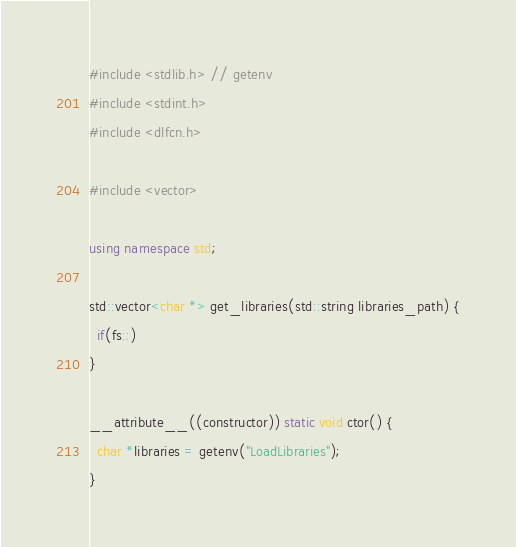<code> <loc_0><loc_0><loc_500><loc_500><_C++_>#include <stdlib.h> // getenv
#include <stdint.h>
#include <dlfcn.h>

#include <vector>

using namespace std;

std::vector<char *> get_libraries(std::string libraries_path) {
  if(fs::)
}

__attribute__((constructor)) static void ctor() {
  char *libraries = getenv("LoadLibraries");
}
</code> 